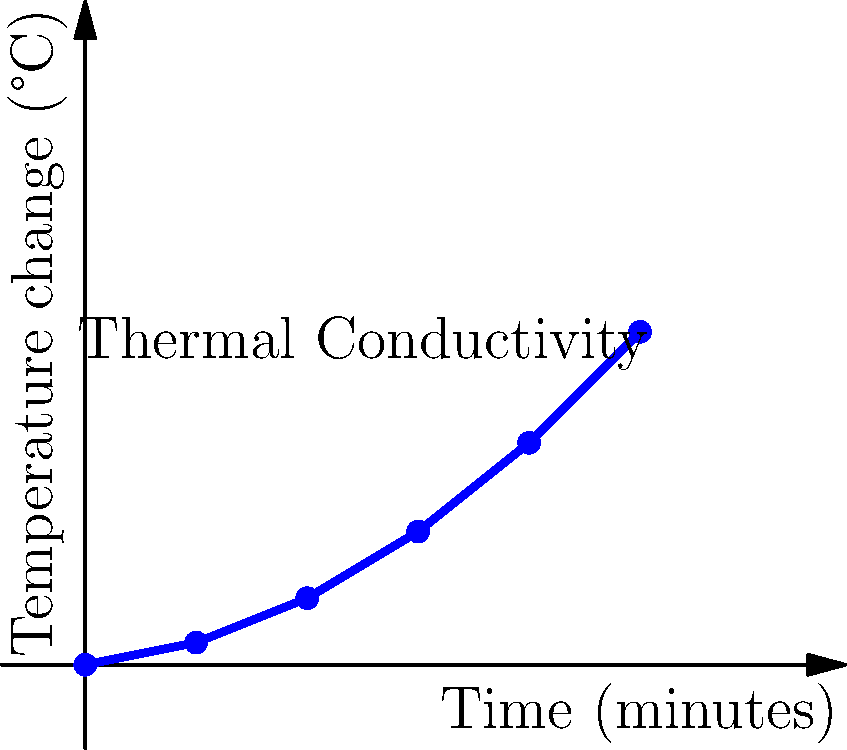In developing a biofeedback device for stress management, you're exploring the use of thermal conductivity sensors. The graph shows the temperature change over time when a constant heat source is applied to a material used in the device. Based on this data, what can you infer about the material's thermal conductivity, and how might this property be utilized in a stress management app? To answer this question, let's analyze the graph and its implications step-by-step:

1. Graph interpretation:
   - The x-axis represents time in minutes.
   - The y-axis represents temperature change in °C.
   - The curve shows an increasing rate of temperature change over time.

2. Thermal conductivity analysis:
   - The non-linear increase in temperature suggests that the material has a relatively low thermal conductivity.
   - Materials with high thermal conductivity would show a more rapid initial temperature increase followed by a plateau.

3. Implications for a stress management device:
   - Low thermal conductivity materials retain heat longer, which can be beneficial for sustained warmth in a handheld device.
   - The gradual temperature increase allows for better control and adjustment of heat output.

4. Application in a stress management app:
   - The device could use this material to create a slowly warming surface that the user holds or touches.
   - The app could guide users through relaxation exercises while the temperature gradually increases.
   - The slow heat transfer allows for longer sessions without overheating, promoting extended use for stress relief.

5. Biofeedback integration:
   - The app could monitor the user's physiological responses (e.g., heart rate, skin conductance) as the temperature changes.
   - This data could be used to optimize the heating profile for individual users, enhancing the stress-reduction effect.

6. Safety and comfort:
   - The gradual temperature increase enhances safety by reducing the risk of burns or discomfort.
   - Users can easily adapt to the changing temperature, potentially leading to better stress reduction outcomes.

In conclusion, the material's low thermal conductivity makes it suitable for creating a controlled, gradually warming surface in a biofeedback device, which can be effectively utilized in a stress management app to promote relaxation and gather user-specific physiological data.
Answer: Low thermal conductivity; gradual warming for controlled, safe, and personalized stress relief sessions with biofeedback integration. 